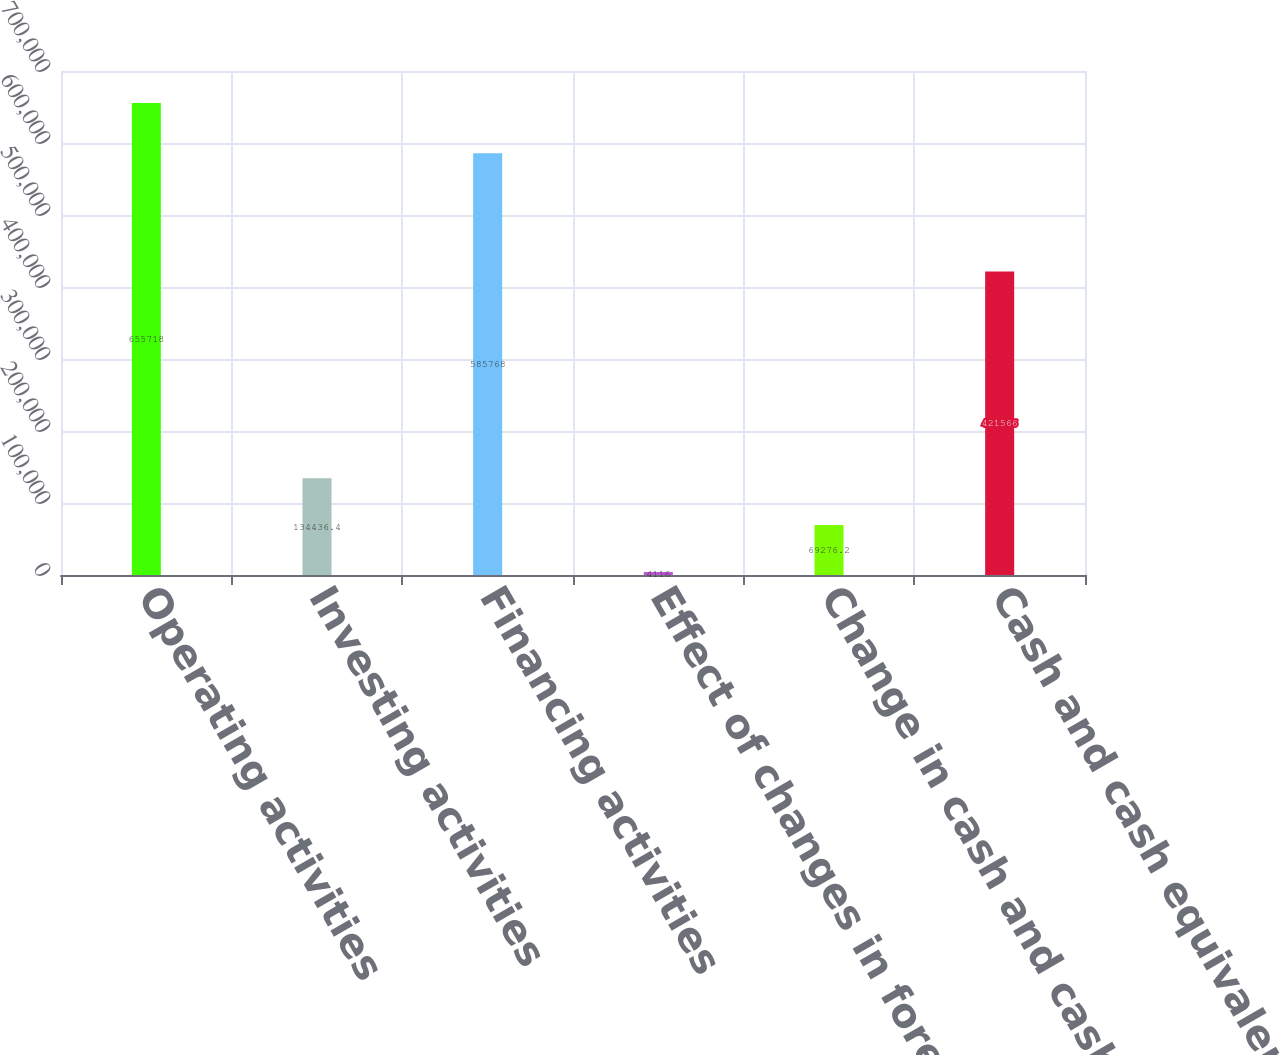Convert chart to OTSL. <chart><loc_0><loc_0><loc_500><loc_500><bar_chart><fcel>Operating activities<fcel>Investing activities<fcel>Financing activities<fcel>Effect of changes in foreign<fcel>Change in cash and cash<fcel>Cash and cash equivalents at<nl><fcel>655718<fcel>134436<fcel>585768<fcel>4116<fcel>69276.2<fcel>421566<nl></chart> 